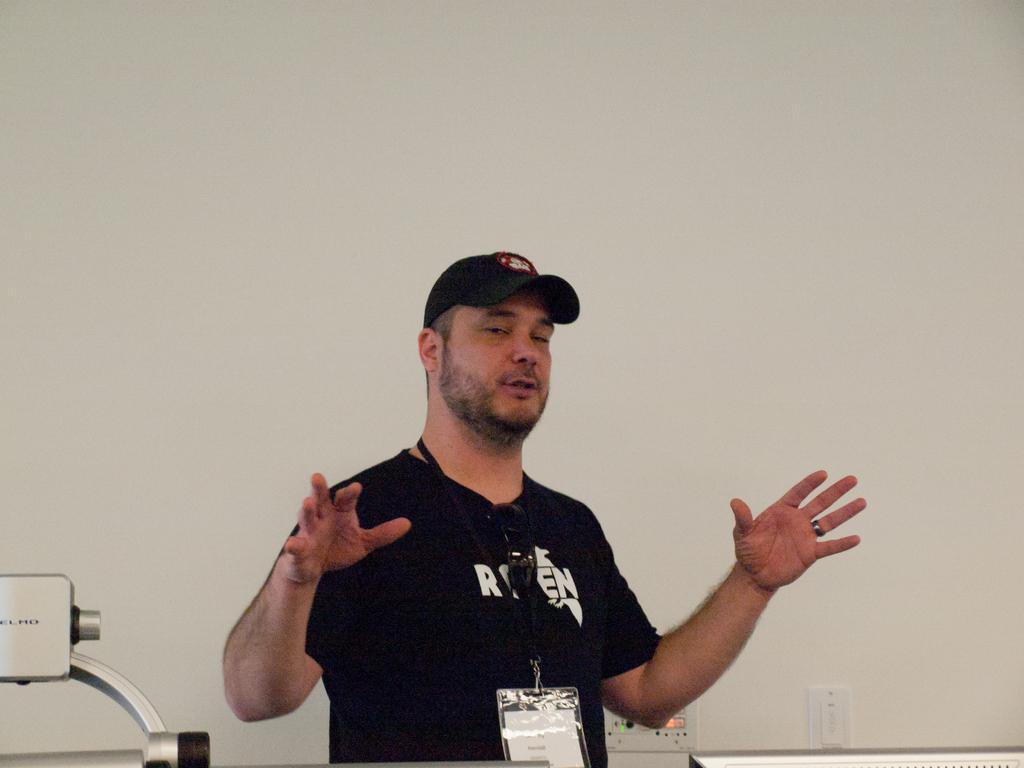In one or two sentences, can you explain what this image depicts? A person is standing wearing a black t shirt, cap and id card. There is a wall behind him. 